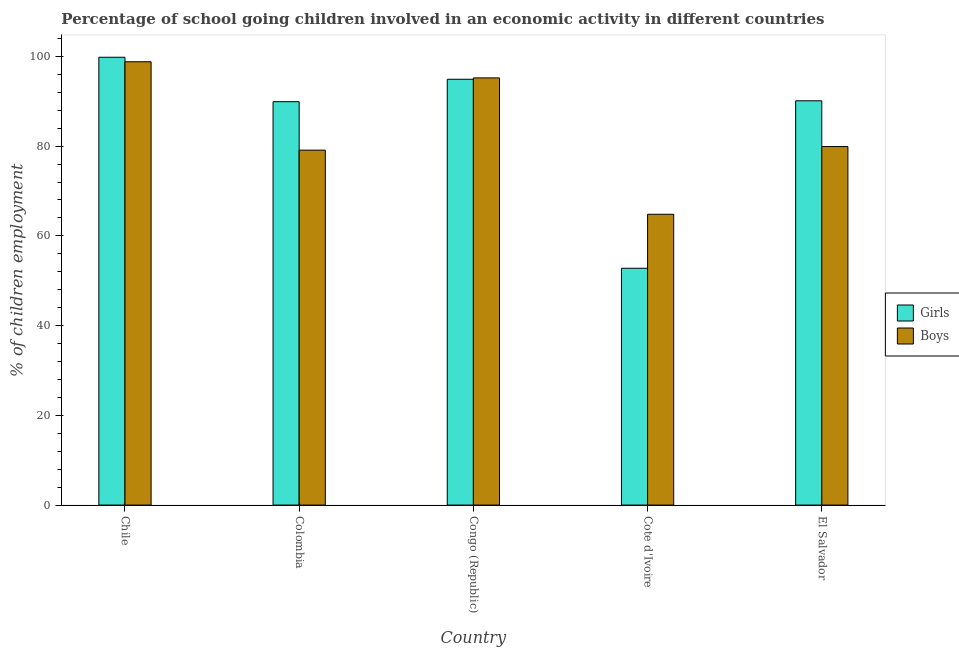How many different coloured bars are there?
Keep it short and to the point. 2. How many groups of bars are there?
Your answer should be compact. 5. Are the number of bars per tick equal to the number of legend labels?
Ensure brevity in your answer.  Yes. How many bars are there on the 2nd tick from the right?
Provide a succinct answer. 2. What is the label of the 1st group of bars from the left?
Ensure brevity in your answer.  Chile. In how many cases, is the number of bars for a given country not equal to the number of legend labels?
Your answer should be very brief. 0. What is the percentage of school going girls in El Salvador?
Keep it short and to the point. 90.1. Across all countries, what is the maximum percentage of school going girls?
Your answer should be very brief. 99.8. Across all countries, what is the minimum percentage of school going girls?
Your answer should be very brief. 52.78. In which country was the percentage of school going boys minimum?
Your answer should be very brief. Cote d'Ivoire. What is the total percentage of school going girls in the graph?
Your answer should be compact. 427.48. What is the difference between the percentage of school going girls in Chile and that in El Salvador?
Keep it short and to the point. 9.7. What is the difference between the percentage of school going boys in Cote d'Ivoire and the percentage of school going girls in Colombia?
Make the answer very short. -25.09. What is the average percentage of school going boys per country?
Your answer should be very brief. 83.56. What is the difference between the percentage of school going boys and percentage of school going girls in Colombia?
Keep it short and to the point. -10.8. What is the ratio of the percentage of school going boys in Colombia to that in El Salvador?
Provide a succinct answer. 0.99. Is the percentage of school going girls in Chile less than that in Congo (Republic)?
Offer a very short reply. No. Is the difference between the percentage of school going girls in Colombia and Cote d'Ivoire greater than the difference between the percentage of school going boys in Colombia and Cote d'Ivoire?
Ensure brevity in your answer.  Yes. What is the difference between the highest and the second highest percentage of school going boys?
Provide a succinct answer. 3.6. What is the difference between the highest and the lowest percentage of school going boys?
Offer a terse response. 33.99. Is the sum of the percentage of school going boys in Congo (Republic) and El Salvador greater than the maximum percentage of school going girls across all countries?
Keep it short and to the point. Yes. What does the 1st bar from the left in El Salvador represents?
Give a very brief answer. Girls. What does the 2nd bar from the right in Congo (Republic) represents?
Make the answer very short. Girls. Does the graph contain grids?
Your answer should be very brief. No. Where does the legend appear in the graph?
Give a very brief answer. Center right. What is the title of the graph?
Provide a short and direct response. Percentage of school going children involved in an economic activity in different countries. Does "Formally registered" appear as one of the legend labels in the graph?
Ensure brevity in your answer.  No. What is the label or title of the X-axis?
Your answer should be compact. Country. What is the label or title of the Y-axis?
Give a very brief answer. % of children employment. What is the % of children employment in Girls in Chile?
Provide a short and direct response. 99.8. What is the % of children employment in Boys in Chile?
Give a very brief answer. 98.8. What is the % of children employment in Girls in Colombia?
Offer a very short reply. 89.9. What is the % of children employment of Boys in Colombia?
Provide a short and direct response. 79.1. What is the % of children employment in Girls in Congo (Republic)?
Your answer should be very brief. 94.9. What is the % of children employment of Boys in Congo (Republic)?
Your answer should be compact. 95.2. What is the % of children employment in Girls in Cote d'Ivoire?
Offer a terse response. 52.78. What is the % of children employment in Boys in Cote d'Ivoire?
Your answer should be very brief. 64.81. What is the % of children employment of Girls in El Salvador?
Offer a very short reply. 90.1. What is the % of children employment in Boys in El Salvador?
Make the answer very short. 79.9. Across all countries, what is the maximum % of children employment of Girls?
Keep it short and to the point. 99.8. Across all countries, what is the maximum % of children employment in Boys?
Your response must be concise. 98.8. Across all countries, what is the minimum % of children employment in Girls?
Ensure brevity in your answer.  52.78. Across all countries, what is the minimum % of children employment of Boys?
Your answer should be compact. 64.81. What is the total % of children employment in Girls in the graph?
Provide a short and direct response. 427.48. What is the total % of children employment of Boys in the graph?
Offer a terse response. 417.81. What is the difference between the % of children employment in Boys in Chile and that in Colombia?
Give a very brief answer. 19.7. What is the difference between the % of children employment in Boys in Chile and that in Congo (Republic)?
Provide a succinct answer. 3.6. What is the difference between the % of children employment in Girls in Chile and that in Cote d'Ivoire?
Provide a succinct answer. 47.02. What is the difference between the % of children employment in Boys in Chile and that in Cote d'Ivoire?
Provide a succinct answer. 33.99. What is the difference between the % of children employment in Girls in Chile and that in El Salvador?
Your answer should be very brief. 9.7. What is the difference between the % of children employment in Boys in Colombia and that in Congo (Republic)?
Offer a terse response. -16.1. What is the difference between the % of children employment in Girls in Colombia and that in Cote d'Ivoire?
Provide a short and direct response. 37.12. What is the difference between the % of children employment of Boys in Colombia and that in Cote d'Ivoire?
Provide a succinct answer. 14.29. What is the difference between the % of children employment of Girls in Congo (Republic) and that in Cote d'Ivoire?
Your response must be concise. 42.12. What is the difference between the % of children employment of Boys in Congo (Republic) and that in Cote d'Ivoire?
Ensure brevity in your answer.  30.39. What is the difference between the % of children employment of Girls in Congo (Republic) and that in El Salvador?
Provide a succinct answer. 4.8. What is the difference between the % of children employment of Girls in Cote d'Ivoire and that in El Salvador?
Keep it short and to the point. -37.32. What is the difference between the % of children employment in Boys in Cote d'Ivoire and that in El Salvador?
Your answer should be very brief. -15.09. What is the difference between the % of children employment in Girls in Chile and the % of children employment in Boys in Colombia?
Your answer should be very brief. 20.7. What is the difference between the % of children employment of Girls in Chile and the % of children employment of Boys in Cote d'Ivoire?
Give a very brief answer. 34.99. What is the difference between the % of children employment of Girls in Colombia and the % of children employment of Boys in Congo (Republic)?
Your answer should be very brief. -5.3. What is the difference between the % of children employment in Girls in Colombia and the % of children employment in Boys in Cote d'Ivoire?
Keep it short and to the point. 25.09. What is the difference between the % of children employment in Girls in Colombia and the % of children employment in Boys in El Salvador?
Your answer should be compact. 10. What is the difference between the % of children employment in Girls in Congo (Republic) and the % of children employment in Boys in Cote d'Ivoire?
Ensure brevity in your answer.  30.09. What is the difference between the % of children employment of Girls in Cote d'Ivoire and the % of children employment of Boys in El Salvador?
Keep it short and to the point. -27.12. What is the average % of children employment in Girls per country?
Offer a very short reply. 85.5. What is the average % of children employment in Boys per country?
Make the answer very short. 83.56. What is the difference between the % of children employment of Girls and % of children employment of Boys in Chile?
Ensure brevity in your answer.  1. What is the difference between the % of children employment of Girls and % of children employment of Boys in Congo (Republic)?
Keep it short and to the point. -0.3. What is the difference between the % of children employment in Girls and % of children employment in Boys in Cote d'Ivoire?
Provide a succinct answer. -12.03. What is the ratio of the % of children employment in Girls in Chile to that in Colombia?
Ensure brevity in your answer.  1.11. What is the ratio of the % of children employment of Boys in Chile to that in Colombia?
Provide a succinct answer. 1.25. What is the ratio of the % of children employment of Girls in Chile to that in Congo (Republic)?
Ensure brevity in your answer.  1.05. What is the ratio of the % of children employment of Boys in Chile to that in Congo (Republic)?
Your answer should be compact. 1.04. What is the ratio of the % of children employment of Girls in Chile to that in Cote d'Ivoire?
Keep it short and to the point. 1.89. What is the ratio of the % of children employment in Boys in Chile to that in Cote d'Ivoire?
Offer a very short reply. 1.52. What is the ratio of the % of children employment in Girls in Chile to that in El Salvador?
Your response must be concise. 1.11. What is the ratio of the % of children employment in Boys in Chile to that in El Salvador?
Ensure brevity in your answer.  1.24. What is the ratio of the % of children employment in Girls in Colombia to that in Congo (Republic)?
Offer a terse response. 0.95. What is the ratio of the % of children employment in Boys in Colombia to that in Congo (Republic)?
Your answer should be very brief. 0.83. What is the ratio of the % of children employment in Girls in Colombia to that in Cote d'Ivoire?
Offer a very short reply. 1.7. What is the ratio of the % of children employment of Boys in Colombia to that in Cote d'Ivoire?
Keep it short and to the point. 1.22. What is the ratio of the % of children employment of Boys in Colombia to that in El Salvador?
Provide a succinct answer. 0.99. What is the ratio of the % of children employment in Girls in Congo (Republic) to that in Cote d'Ivoire?
Give a very brief answer. 1.8. What is the ratio of the % of children employment of Boys in Congo (Republic) to that in Cote d'Ivoire?
Make the answer very short. 1.47. What is the ratio of the % of children employment in Girls in Congo (Republic) to that in El Salvador?
Provide a succinct answer. 1.05. What is the ratio of the % of children employment of Boys in Congo (Republic) to that in El Salvador?
Give a very brief answer. 1.19. What is the ratio of the % of children employment of Girls in Cote d'Ivoire to that in El Salvador?
Provide a short and direct response. 0.59. What is the ratio of the % of children employment in Boys in Cote d'Ivoire to that in El Salvador?
Your answer should be compact. 0.81. What is the difference between the highest and the second highest % of children employment of Boys?
Your answer should be compact. 3.6. What is the difference between the highest and the lowest % of children employment of Girls?
Your answer should be compact. 47.02. What is the difference between the highest and the lowest % of children employment of Boys?
Make the answer very short. 33.99. 